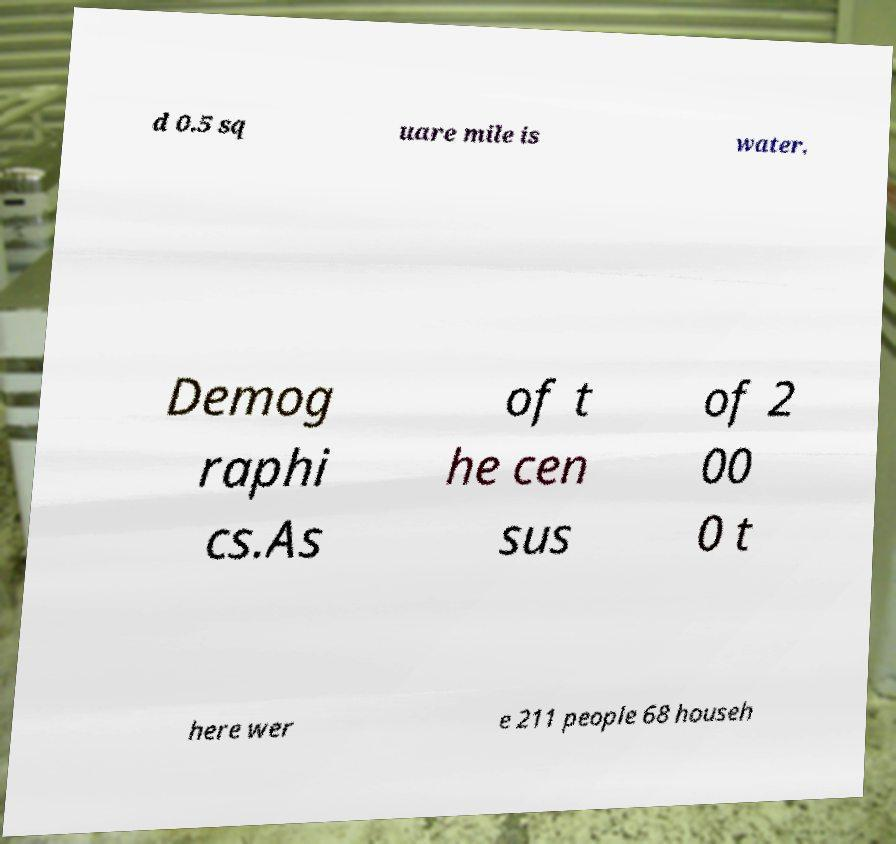I need the written content from this picture converted into text. Can you do that? d 0.5 sq uare mile is water. Demog raphi cs.As of t he cen sus of 2 00 0 t here wer e 211 people 68 househ 